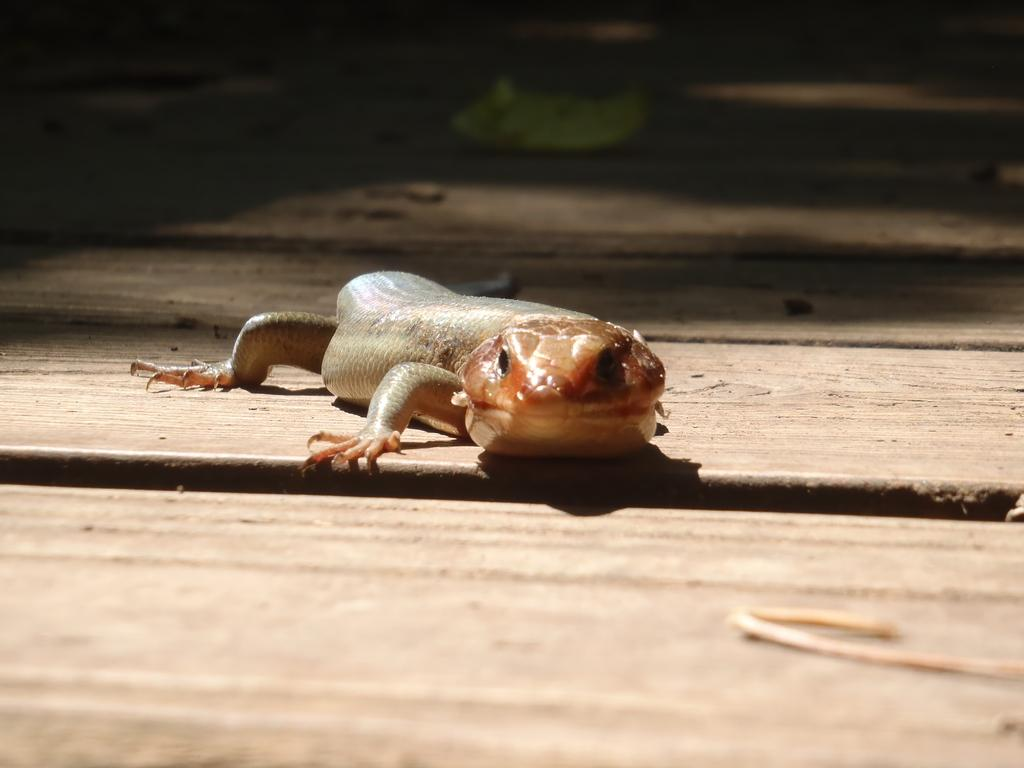What type of animal can be seen in the image? There is a lizard in the image. Where is the lizard located in the image? The lizard is on the floor. What material is the floor made of? The floor is made of wood. What is the color or lighting condition of the background in the image? The background of the image is dark. What direction are the ducks swimming in the image? There are no ducks present in the image, so it is not possible to determine the direction they might be swimming. 